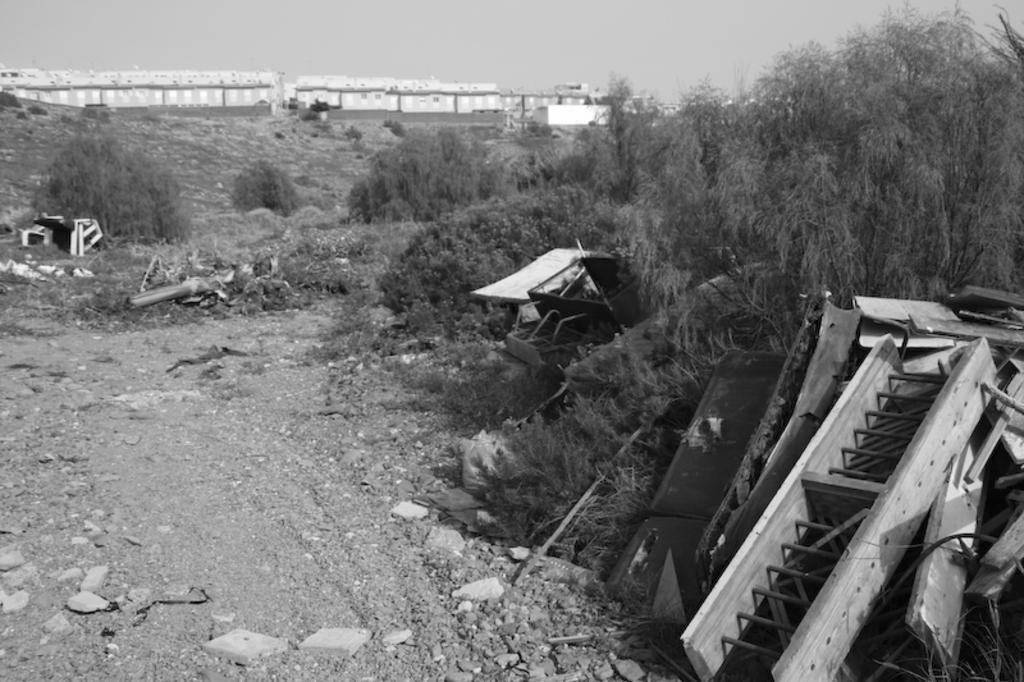What type of objects can be seen in the image that are typically discarded? There are waste objects in the image. What type of natural objects can be seen in the image? There are stones, plants, and trees in the image. What type of man-made structures can be seen in the image? There are buildings in the image. What part of the natural environment is visible in the image? The sky is visible in the image. What type of wire can be seen hanging from the trees in the image? There is no wire hanging from the trees in the image. Can you tell me how many holes are present in the buildings in the image? There is no information about holes in the buildings in the image. Is the grandfather sitting on the stones in the image? There is no grandfather present in the image. 